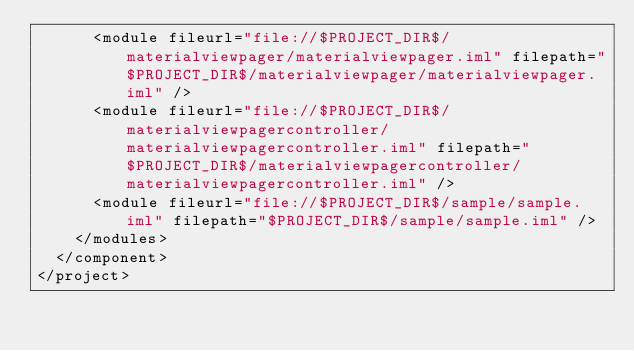Convert code to text. <code><loc_0><loc_0><loc_500><loc_500><_XML_>      <module fileurl="file://$PROJECT_DIR$/materialviewpager/materialviewpager.iml" filepath="$PROJECT_DIR$/materialviewpager/materialviewpager.iml" />
      <module fileurl="file://$PROJECT_DIR$/materialviewpagercontroller/materialviewpagercontroller.iml" filepath="$PROJECT_DIR$/materialviewpagercontroller/materialviewpagercontroller.iml" />
      <module fileurl="file://$PROJECT_DIR$/sample/sample.iml" filepath="$PROJECT_DIR$/sample/sample.iml" />
    </modules>
  </component>
</project></code> 